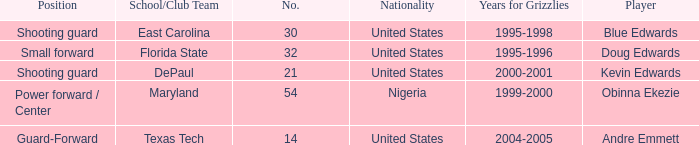Which school/club team did blue edwards play for East Carolina. 